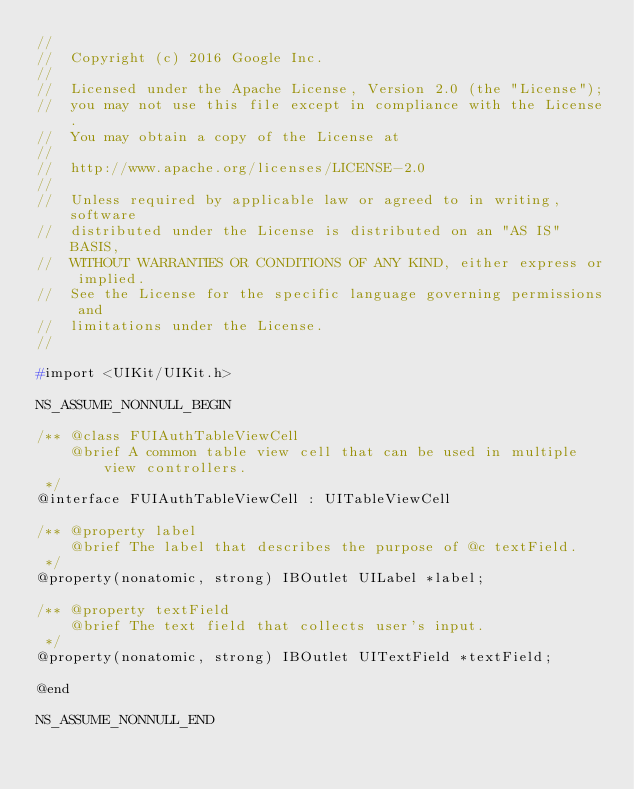<code> <loc_0><loc_0><loc_500><loc_500><_C_>//
//  Copyright (c) 2016 Google Inc.
//
//  Licensed under the Apache License, Version 2.0 (the "License");
//  you may not use this file except in compliance with the License.
//  You may obtain a copy of the License at
//
//  http://www.apache.org/licenses/LICENSE-2.0
//
//  Unless required by applicable law or agreed to in writing, software
//  distributed under the License is distributed on an "AS IS" BASIS,
//  WITHOUT WARRANTIES OR CONDITIONS OF ANY KIND, either express or implied.
//  See the License for the specific language governing permissions and
//  limitations under the License.
//

#import <UIKit/UIKit.h>

NS_ASSUME_NONNULL_BEGIN

/** @class FUIAuthTableViewCell
    @brief A common table view cell that can be used in multiple view controllers.
 */
@interface FUIAuthTableViewCell : UITableViewCell

/** @property label
    @brief The label that describes the purpose of @c textField.
 */
@property(nonatomic, strong) IBOutlet UILabel *label;

/** @property textField
    @brief The text field that collects user's input.
 */
@property(nonatomic, strong) IBOutlet UITextField *textField;

@end

NS_ASSUME_NONNULL_END
</code> 